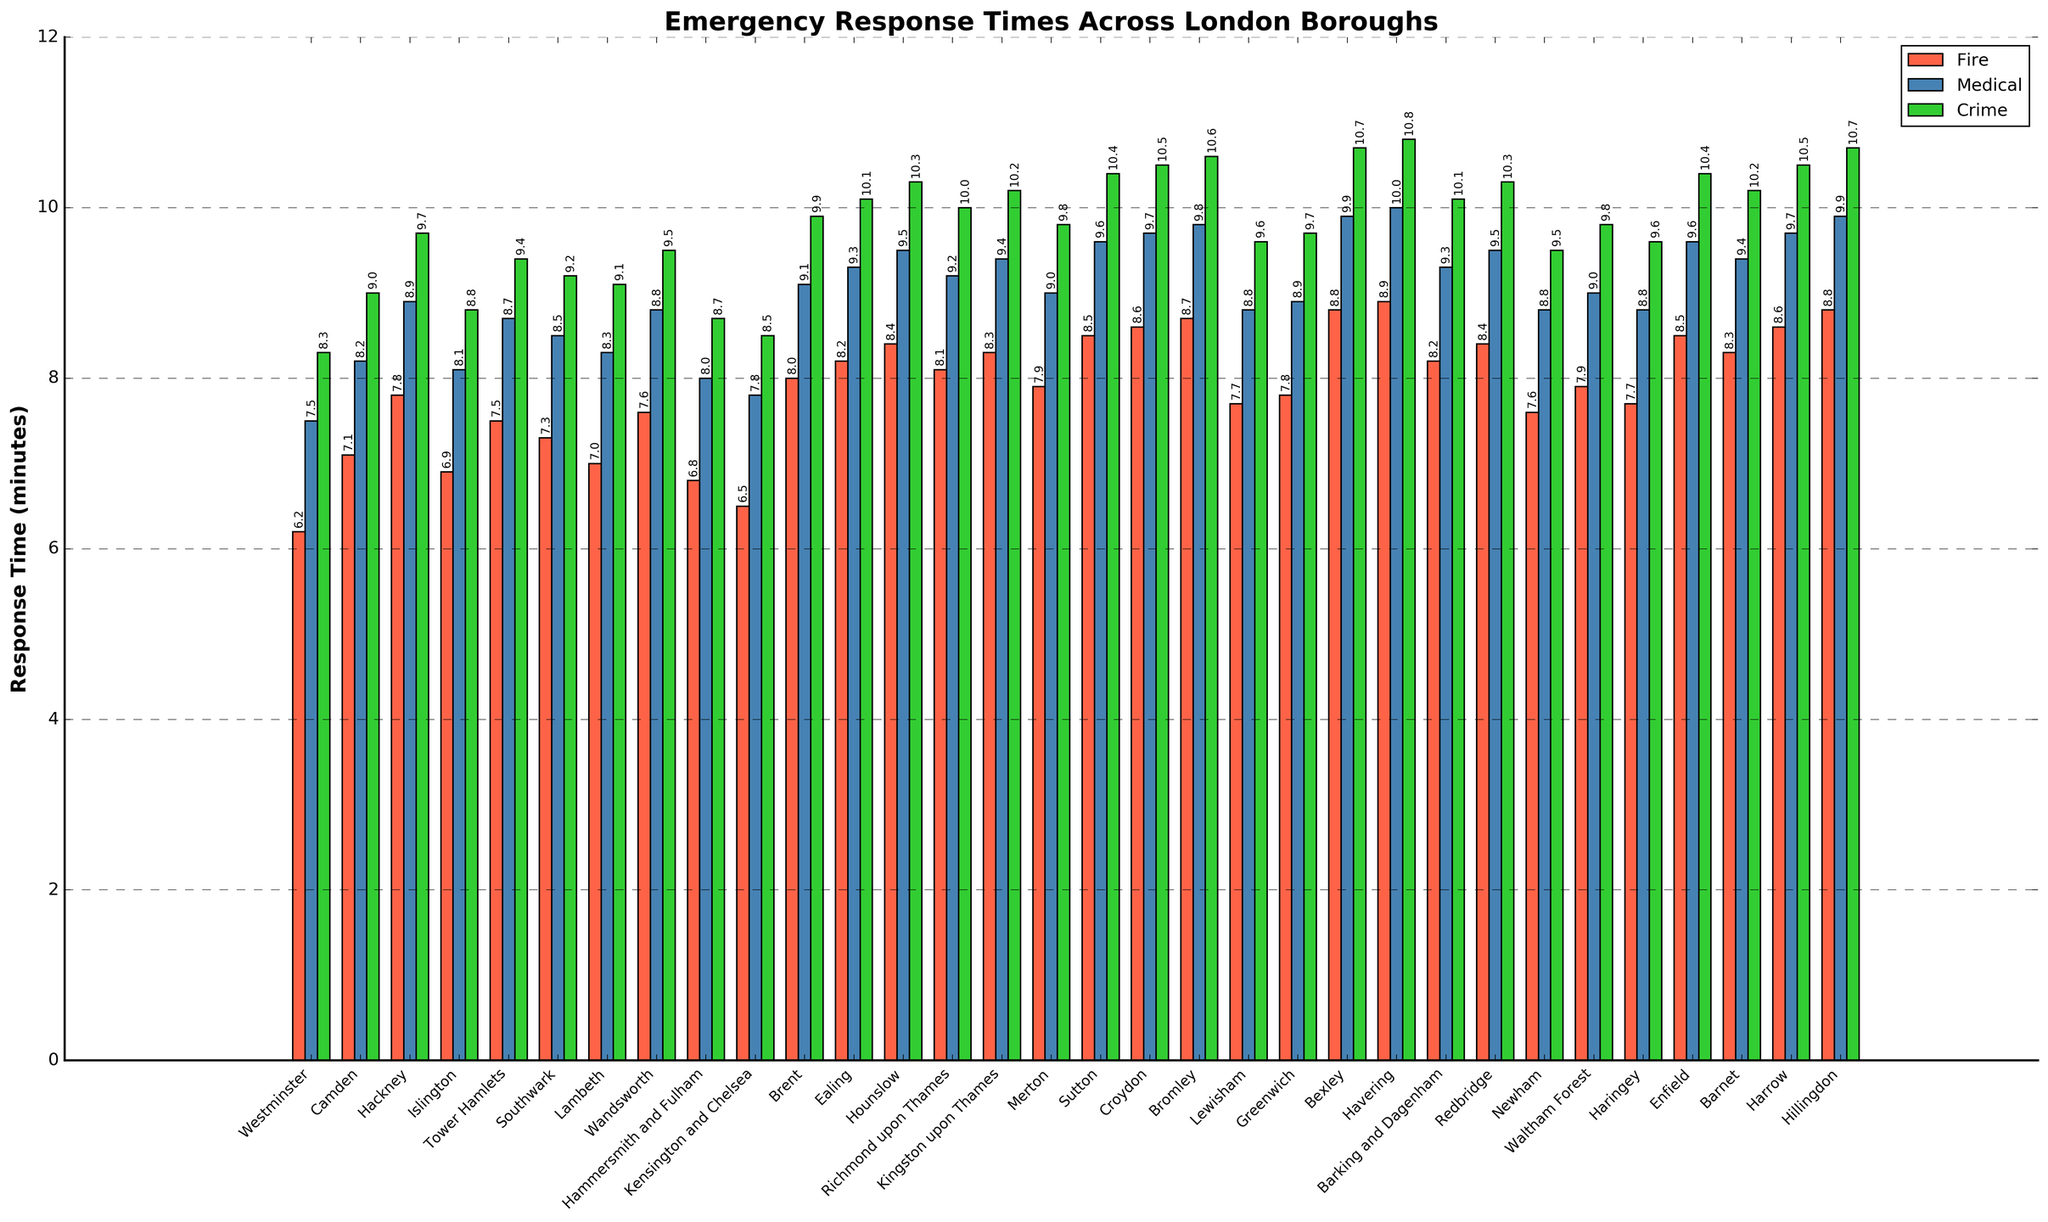Which borough has the fastest fire response time? Look at the shortest bar in the "Fire" category, which is shown in red. The shortest bar is for Westminster.
Answer: Westminster What is the difference in medical response times between Bromley and Greenwich? Find the bar heights for the two boroughs in the "Medical" category, which is shown in blue. Bromley's medical response time is 9.8 minutes, and Greenwich's is 8.9 minutes. The difference is 9.8 - 8.9 = 0.9 minutes.
Answer: 0.9 minutes Which incident type generally has the longest response times? Compare the heights of the bars across the "Fire", "Medical", and "Crime" categories. The "Crime" category, shown in green, generally has the tallest bars.
Answer: Crime What is the average fire response time across all boroughs? Add up all the fire response times and divide by the number of boroughs. Here we have 33 boroughs. The sum of fire response times is 238.8 minutes, so the average is 238.8 / 33 ≈ 7.24 minutes.
Answer: 7.24 minutes Which borough has the highest crime response time? Look for the tallest bar in the "Crime" category, which is shown in green. The tallest bar is for Havering.
Answer: Havering How much higher is the crime response time in Hillingdon compared to Kensington and Chelsea? Check the heights of the "Crime" category bars for both boroughs. Hillingdon has a response time of 10.7 minutes, while Kensington and Chelsea have 8.5 minutes. The difference is 10.7 - 8.5 = 2.2 minutes.
Answer: 2.2 minutes What is the range of medical response times across the boroughs? Identify the highest and lowest medical response times in the "Medical" category. The highest is 10.0 minutes in Havering, and the lowest is 7.5 minutes in Westminster. The range is 10.0 - 7.5 = 2.5 minutes.
Answer: 2.5 minutes Which borough has nearly equal response times for all three types of incidents? Look for a borough where the bars for "Fire", "Medical", and "Crime" are close in height. Westminster has fire response time 6.2, medical response time 7.5, and crime response time 8.3, which are relatively close.
Answer: Westminster Which types of incidents have the closest median response times across all boroughs? Calculate the median response times for each incident type. Given there are 33 boroughs, the median is the 17th value when arranged in ascending order. The closely situated values will belong to crime and medical response times - both have median values around 9.4 and 9.0 minutes respectively.
Answer: Crime and Medical Is there any borough where the fire response time is significantly below the average? Find the average fire response time (7.24 minutes as previously calculated). Look for boroughs with fire response times significantly lower than this. Westminster (6.2 minutes) and Kensington and Chelsea (6.5 minutes) are examples.
Answer: Westminster and Kensington and Chelsea 